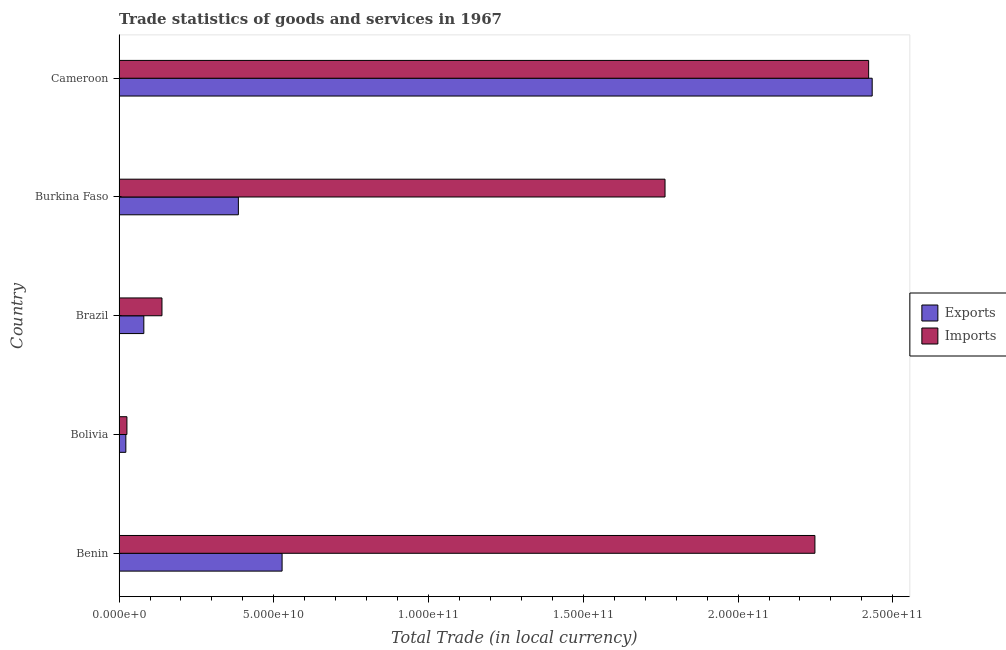How many different coloured bars are there?
Your answer should be compact. 2. How many groups of bars are there?
Your answer should be very brief. 5. Are the number of bars per tick equal to the number of legend labels?
Provide a short and direct response. Yes. How many bars are there on the 1st tick from the top?
Offer a terse response. 2. How many bars are there on the 4th tick from the bottom?
Your response must be concise. 2. What is the label of the 3rd group of bars from the top?
Your answer should be compact. Brazil. In how many cases, is the number of bars for a given country not equal to the number of legend labels?
Make the answer very short. 0. What is the export of goods and services in Benin?
Ensure brevity in your answer.  5.27e+1. Across all countries, what is the maximum imports of goods and services?
Provide a short and direct response. 2.42e+11. Across all countries, what is the minimum imports of goods and services?
Your answer should be compact. 2.54e+09. In which country was the imports of goods and services maximum?
Your answer should be compact. Cameroon. What is the total export of goods and services in the graph?
Make the answer very short. 3.45e+11. What is the difference between the export of goods and services in Benin and that in Brazil?
Make the answer very short. 4.47e+1. What is the difference between the export of goods and services in Bolivia and the imports of goods and services in Burkina Faso?
Offer a terse response. -1.74e+11. What is the average imports of goods and services per country?
Your response must be concise. 1.32e+11. What is the difference between the imports of goods and services and export of goods and services in Bolivia?
Your answer should be very brief. 3.51e+08. In how many countries, is the imports of goods and services greater than 160000000000 LCU?
Keep it short and to the point. 3. What is the ratio of the export of goods and services in Brazil to that in Burkina Faso?
Your response must be concise. 0.21. Is the export of goods and services in Bolivia less than that in Burkina Faso?
Your answer should be very brief. Yes. Is the difference between the imports of goods and services in Brazil and Burkina Faso greater than the difference between the export of goods and services in Brazil and Burkina Faso?
Provide a short and direct response. No. What is the difference between the highest and the second highest imports of goods and services?
Your answer should be very brief. 1.74e+1. What is the difference between the highest and the lowest export of goods and services?
Your answer should be very brief. 2.41e+11. In how many countries, is the export of goods and services greater than the average export of goods and services taken over all countries?
Your answer should be compact. 1. What does the 2nd bar from the top in Brazil represents?
Your answer should be very brief. Exports. What does the 1st bar from the bottom in Cameroon represents?
Make the answer very short. Exports. How many countries are there in the graph?
Give a very brief answer. 5. What is the difference between two consecutive major ticks on the X-axis?
Give a very brief answer. 5.00e+1. Does the graph contain any zero values?
Your answer should be very brief. No. How are the legend labels stacked?
Your answer should be compact. Vertical. What is the title of the graph?
Make the answer very short. Trade statistics of goods and services in 1967. What is the label or title of the X-axis?
Provide a succinct answer. Total Trade (in local currency). What is the Total Trade (in local currency) of Exports in Benin?
Make the answer very short. 5.27e+1. What is the Total Trade (in local currency) in Imports in Benin?
Provide a succinct answer. 2.25e+11. What is the Total Trade (in local currency) in Exports in Bolivia?
Keep it short and to the point. 2.19e+09. What is the Total Trade (in local currency) in Imports in Bolivia?
Keep it short and to the point. 2.54e+09. What is the Total Trade (in local currency) in Exports in Brazil?
Your response must be concise. 8.01e+09. What is the Total Trade (in local currency) in Imports in Brazil?
Make the answer very short. 1.39e+1. What is the Total Trade (in local currency) in Exports in Burkina Faso?
Your answer should be compact. 3.86e+1. What is the Total Trade (in local currency) in Imports in Burkina Faso?
Your answer should be compact. 1.76e+11. What is the Total Trade (in local currency) of Exports in Cameroon?
Provide a succinct answer. 2.43e+11. What is the Total Trade (in local currency) in Imports in Cameroon?
Your response must be concise. 2.42e+11. Across all countries, what is the maximum Total Trade (in local currency) of Exports?
Provide a short and direct response. 2.43e+11. Across all countries, what is the maximum Total Trade (in local currency) in Imports?
Make the answer very short. 2.42e+11. Across all countries, what is the minimum Total Trade (in local currency) of Exports?
Ensure brevity in your answer.  2.19e+09. Across all countries, what is the minimum Total Trade (in local currency) of Imports?
Your response must be concise. 2.54e+09. What is the total Total Trade (in local currency) of Exports in the graph?
Your answer should be compact. 3.45e+11. What is the total Total Trade (in local currency) of Imports in the graph?
Your response must be concise. 6.60e+11. What is the difference between the Total Trade (in local currency) in Exports in Benin and that in Bolivia?
Offer a terse response. 5.05e+1. What is the difference between the Total Trade (in local currency) in Imports in Benin and that in Bolivia?
Ensure brevity in your answer.  2.22e+11. What is the difference between the Total Trade (in local currency) of Exports in Benin and that in Brazil?
Your answer should be compact. 4.47e+1. What is the difference between the Total Trade (in local currency) of Imports in Benin and that in Brazil?
Provide a succinct answer. 2.11e+11. What is the difference between the Total Trade (in local currency) of Exports in Benin and that in Burkina Faso?
Your answer should be very brief. 1.41e+1. What is the difference between the Total Trade (in local currency) in Imports in Benin and that in Burkina Faso?
Your answer should be compact. 4.84e+1. What is the difference between the Total Trade (in local currency) of Exports in Benin and that in Cameroon?
Your answer should be very brief. -1.91e+11. What is the difference between the Total Trade (in local currency) of Imports in Benin and that in Cameroon?
Offer a very short reply. -1.74e+1. What is the difference between the Total Trade (in local currency) in Exports in Bolivia and that in Brazil?
Your response must be concise. -5.81e+09. What is the difference between the Total Trade (in local currency) of Imports in Bolivia and that in Brazil?
Your answer should be compact. -1.13e+1. What is the difference between the Total Trade (in local currency) of Exports in Bolivia and that in Burkina Faso?
Give a very brief answer. -3.64e+1. What is the difference between the Total Trade (in local currency) of Imports in Bolivia and that in Burkina Faso?
Your response must be concise. -1.74e+11. What is the difference between the Total Trade (in local currency) in Exports in Bolivia and that in Cameroon?
Offer a terse response. -2.41e+11. What is the difference between the Total Trade (in local currency) in Imports in Bolivia and that in Cameroon?
Ensure brevity in your answer.  -2.40e+11. What is the difference between the Total Trade (in local currency) in Exports in Brazil and that in Burkina Faso?
Provide a short and direct response. -3.05e+1. What is the difference between the Total Trade (in local currency) in Imports in Brazil and that in Burkina Faso?
Make the answer very short. -1.63e+11. What is the difference between the Total Trade (in local currency) in Exports in Brazil and that in Cameroon?
Give a very brief answer. -2.35e+11. What is the difference between the Total Trade (in local currency) in Imports in Brazil and that in Cameroon?
Make the answer very short. -2.28e+11. What is the difference between the Total Trade (in local currency) in Exports in Burkina Faso and that in Cameroon?
Keep it short and to the point. -2.05e+11. What is the difference between the Total Trade (in local currency) of Imports in Burkina Faso and that in Cameroon?
Provide a short and direct response. -6.58e+1. What is the difference between the Total Trade (in local currency) of Exports in Benin and the Total Trade (in local currency) of Imports in Bolivia?
Ensure brevity in your answer.  5.01e+1. What is the difference between the Total Trade (in local currency) in Exports in Benin and the Total Trade (in local currency) in Imports in Brazil?
Make the answer very short. 3.88e+1. What is the difference between the Total Trade (in local currency) of Exports in Benin and the Total Trade (in local currency) of Imports in Burkina Faso?
Your answer should be compact. -1.24e+11. What is the difference between the Total Trade (in local currency) in Exports in Benin and the Total Trade (in local currency) in Imports in Cameroon?
Give a very brief answer. -1.90e+11. What is the difference between the Total Trade (in local currency) in Exports in Bolivia and the Total Trade (in local currency) in Imports in Brazil?
Your response must be concise. -1.17e+1. What is the difference between the Total Trade (in local currency) of Exports in Bolivia and the Total Trade (in local currency) of Imports in Burkina Faso?
Your answer should be compact. -1.74e+11. What is the difference between the Total Trade (in local currency) in Exports in Bolivia and the Total Trade (in local currency) in Imports in Cameroon?
Offer a terse response. -2.40e+11. What is the difference between the Total Trade (in local currency) of Exports in Brazil and the Total Trade (in local currency) of Imports in Burkina Faso?
Keep it short and to the point. -1.68e+11. What is the difference between the Total Trade (in local currency) in Exports in Brazil and the Total Trade (in local currency) in Imports in Cameroon?
Provide a succinct answer. -2.34e+11. What is the difference between the Total Trade (in local currency) of Exports in Burkina Faso and the Total Trade (in local currency) of Imports in Cameroon?
Your response must be concise. -2.04e+11. What is the average Total Trade (in local currency) in Exports per country?
Ensure brevity in your answer.  6.90e+1. What is the average Total Trade (in local currency) in Imports per country?
Offer a very short reply. 1.32e+11. What is the difference between the Total Trade (in local currency) in Exports and Total Trade (in local currency) in Imports in Benin?
Keep it short and to the point. -1.72e+11. What is the difference between the Total Trade (in local currency) of Exports and Total Trade (in local currency) of Imports in Bolivia?
Give a very brief answer. -3.51e+08. What is the difference between the Total Trade (in local currency) in Exports and Total Trade (in local currency) in Imports in Brazil?
Your answer should be compact. -5.86e+09. What is the difference between the Total Trade (in local currency) of Exports and Total Trade (in local currency) of Imports in Burkina Faso?
Offer a very short reply. -1.38e+11. What is the difference between the Total Trade (in local currency) of Exports and Total Trade (in local currency) of Imports in Cameroon?
Your answer should be compact. 1.15e+09. What is the ratio of the Total Trade (in local currency) of Exports in Benin to that in Bolivia?
Provide a succinct answer. 24.02. What is the ratio of the Total Trade (in local currency) of Imports in Benin to that in Bolivia?
Your answer should be compact. 88.4. What is the ratio of the Total Trade (in local currency) in Exports in Benin to that in Brazil?
Keep it short and to the point. 6.58. What is the ratio of the Total Trade (in local currency) of Imports in Benin to that in Brazil?
Your answer should be compact. 16.21. What is the ratio of the Total Trade (in local currency) of Exports in Benin to that in Burkina Faso?
Offer a very short reply. 1.37. What is the ratio of the Total Trade (in local currency) of Imports in Benin to that in Burkina Faso?
Give a very brief answer. 1.27. What is the ratio of the Total Trade (in local currency) of Exports in Benin to that in Cameroon?
Offer a terse response. 0.22. What is the ratio of the Total Trade (in local currency) of Imports in Benin to that in Cameroon?
Offer a very short reply. 0.93. What is the ratio of the Total Trade (in local currency) of Exports in Bolivia to that in Brazil?
Make the answer very short. 0.27. What is the ratio of the Total Trade (in local currency) of Imports in Bolivia to that in Brazil?
Make the answer very short. 0.18. What is the ratio of the Total Trade (in local currency) in Exports in Bolivia to that in Burkina Faso?
Give a very brief answer. 0.06. What is the ratio of the Total Trade (in local currency) in Imports in Bolivia to that in Burkina Faso?
Your response must be concise. 0.01. What is the ratio of the Total Trade (in local currency) of Exports in Bolivia to that in Cameroon?
Provide a succinct answer. 0.01. What is the ratio of the Total Trade (in local currency) of Imports in Bolivia to that in Cameroon?
Your answer should be compact. 0.01. What is the ratio of the Total Trade (in local currency) in Exports in Brazil to that in Burkina Faso?
Offer a very short reply. 0.21. What is the ratio of the Total Trade (in local currency) of Imports in Brazil to that in Burkina Faso?
Ensure brevity in your answer.  0.08. What is the ratio of the Total Trade (in local currency) in Exports in Brazil to that in Cameroon?
Offer a terse response. 0.03. What is the ratio of the Total Trade (in local currency) of Imports in Brazil to that in Cameroon?
Provide a succinct answer. 0.06. What is the ratio of the Total Trade (in local currency) in Exports in Burkina Faso to that in Cameroon?
Your response must be concise. 0.16. What is the ratio of the Total Trade (in local currency) of Imports in Burkina Faso to that in Cameroon?
Ensure brevity in your answer.  0.73. What is the difference between the highest and the second highest Total Trade (in local currency) in Exports?
Provide a short and direct response. 1.91e+11. What is the difference between the highest and the second highest Total Trade (in local currency) of Imports?
Offer a terse response. 1.74e+1. What is the difference between the highest and the lowest Total Trade (in local currency) in Exports?
Your answer should be compact. 2.41e+11. What is the difference between the highest and the lowest Total Trade (in local currency) in Imports?
Give a very brief answer. 2.40e+11. 